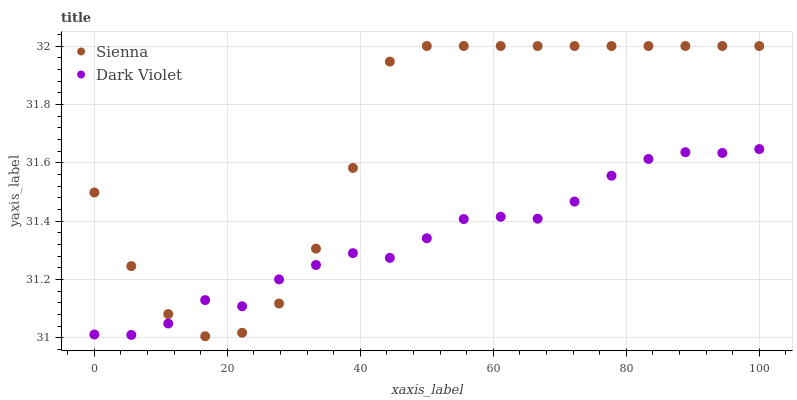Does Dark Violet have the minimum area under the curve?
Answer yes or no. Yes. Does Sienna have the maximum area under the curve?
Answer yes or no. Yes. Does Dark Violet have the maximum area under the curve?
Answer yes or no. No. Is Dark Violet the smoothest?
Answer yes or no. Yes. Is Sienna the roughest?
Answer yes or no. Yes. Is Dark Violet the roughest?
Answer yes or no. No. Does Sienna have the lowest value?
Answer yes or no. Yes. Does Dark Violet have the lowest value?
Answer yes or no. No. Does Sienna have the highest value?
Answer yes or no. Yes. Does Dark Violet have the highest value?
Answer yes or no. No. Does Sienna intersect Dark Violet?
Answer yes or no. Yes. Is Sienna less than Dark Violet?
Answer yes or no. No. Is Sienna greater than Dark Violet?
Answer yes or no. No. 